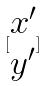<formula> <loc_0><loc_0><loc_500><loc_500>[ \begin{matrix} x ^ { \prime } \\ y ^ { \prime } \end{matrix} ]</formula> 